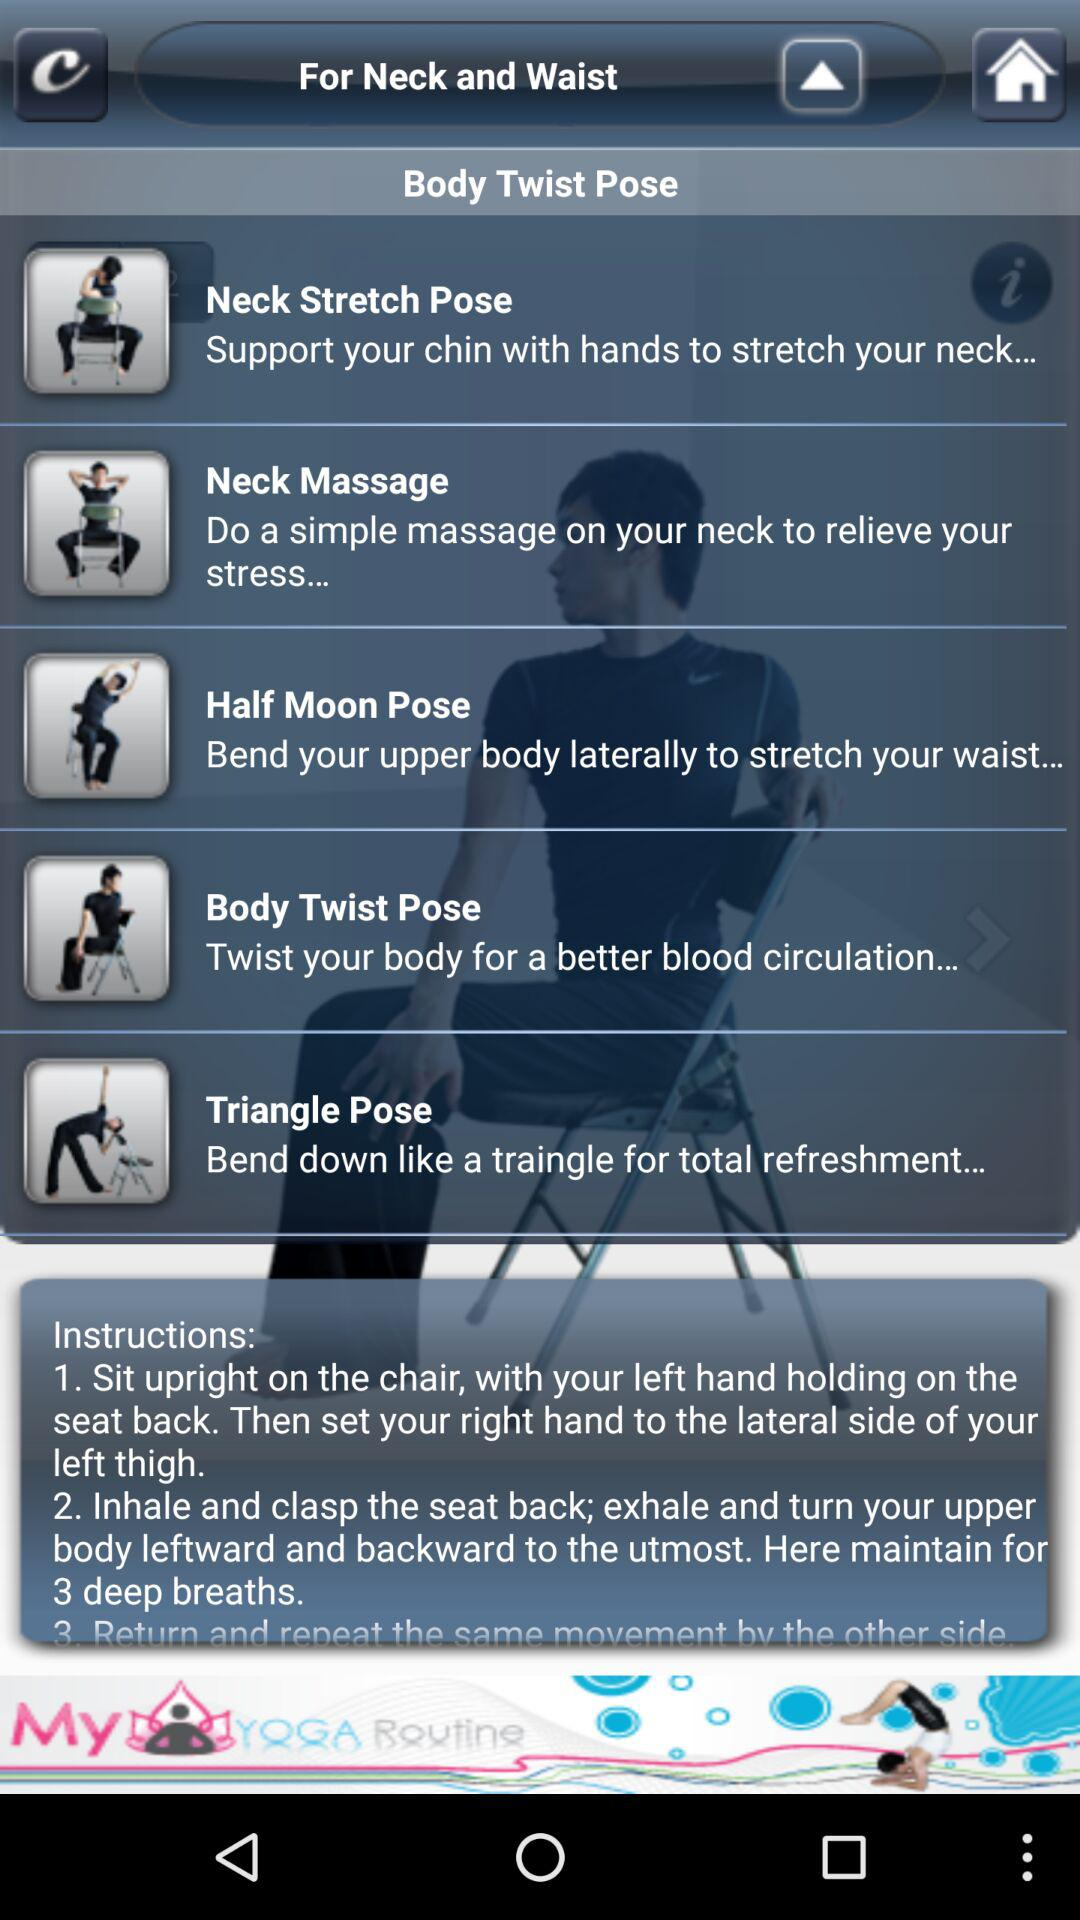Which pose is the last one?
Answer the question using a single word or phrase. Triangle Pose 